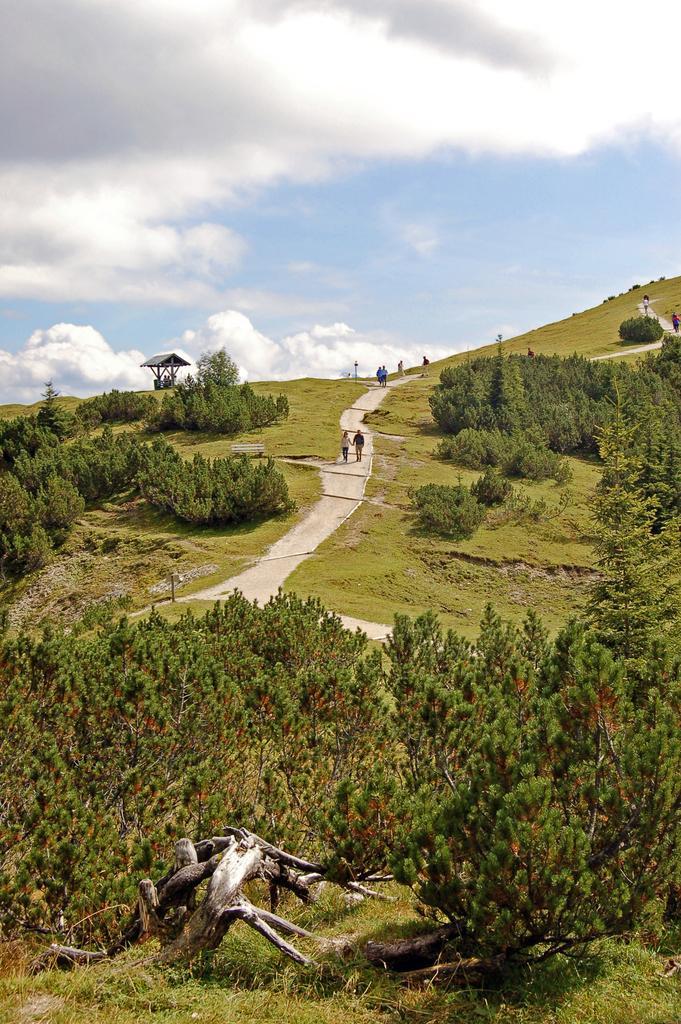Describe this image in one or two sentences. In the image the area is surrounded with a lot of greenery and in between the grass there is a path and few people were walking on that path. 